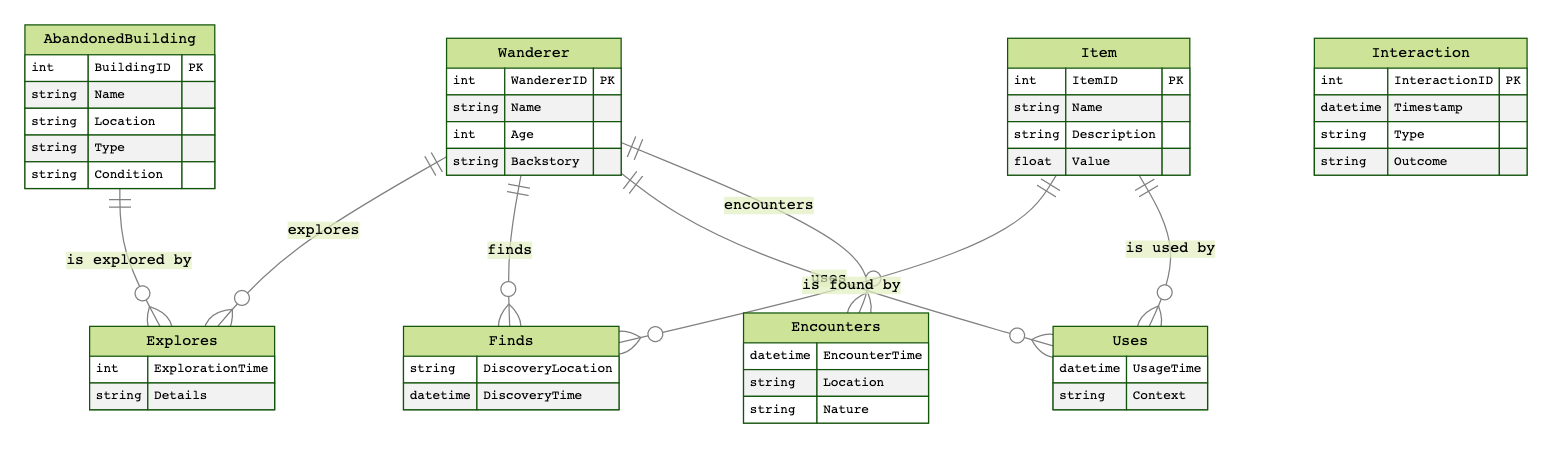What are the attributes of a Wanderer? The entity "Wanderer" includes the attributes: WandererID, Name, Age, and Backstory, which are directly listed under it in the diagram.
Answer: WandererID, Name, Age, Backstory How many relationships are there between Wanderers and Items? The diagram shows that a Wanderer can find and use items, resulting in two distinct relationships (Finds and Uses) between Wanderers and Items.
Answer: 2 What is the relationship type between Wanderers? The diagram indicates that Wanderers have a relationship called "Encounters" which accounts for their interactions with each other.
Answer: Encounters What is one attribute of an AbandonedBuilding? The entity "AbandonedBuilding" contains multiple attributes, one of which is the Name used to identify a particular building.
Answer: Name Which entity contains the DiscoveryLocation attribute? The attribute "DiscoveryLocation" is associated with the relationship "Finds" in the context of a Wanderer discovering an item, reflecting the details of the interaction.
Answer: Finds How many entities are depicted in the diagram? The diagram lists four distinct entities: Wanderer, AbandonedBuilding, Item, and Interaction. Counting these gives the total number of entities.
Answer: 4 What is the condition type available for AbandonedBuilding? Under the "AbandonedBuilding" entity, the attribute "Condition" refers to the state of the building, describing its physical status.
Answer: Condition What is the timestamp attribute used for in the Interaction entity? The "Timestamp" attribute in the "Interaction" entity captures the exact date and time of different interactions involving Wanderers, indicating when they occur.
Answer: Timestamp What are the two types of relationships involving Items? The diagram specifies that Items are related to Wanderers through two relationships: "Finds" (when a Wanderer discovers an item) and "Uses" (when a Wanderer utilizes an item).
Answer: Finds, Uses 